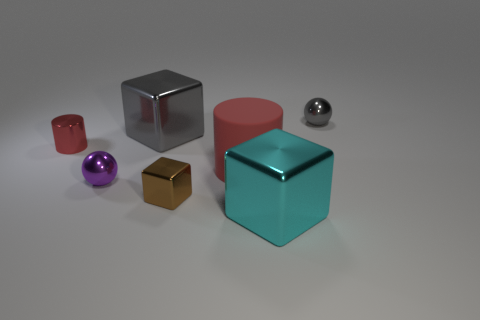Do the small shiny cylinder and the cylinder in front of the metal cylinder have the same color?
Your answer should be compact. Yes. What number of cylinders are large gray metal objects or large gray matte objects?
Give a very brief answer. 0. There is a shiny sphere that is behind the large thing on the left side of the red matte cylinder that is left of the large cyan block; what is its size?
Offer a very short reply. Small. Are there any matte objects left of the red rubber object?
Your response must be concise. No. What number of objects are tiny shiny things that are behind the tiny red shiny object or large red matte things?
Your answer should be very brief. 2. What size is the cyan cube that is the same material as the small purple thing?
Your answer should be very brief. Large. There is a brown cube; is its size the same as the gray metallic thing that is on the left side of the large cyan shiny thing?
Make the answer very short. No. What color is the metallic block that is both in front of the large rubber cylinder and on the left side of the rubber thing?
Offer a very short reply. Brown. What number of objects are either shiny balls that are in front of the big gray shiny cube or big cubes that are in front of the purple metal sphere?
Give a very brief answer. 2. There is a cylinder that is in front of the red cylinder to the left of the gray object that is to the left of the large cyan object; what color is it?
Provide a short and direct response. Red. 